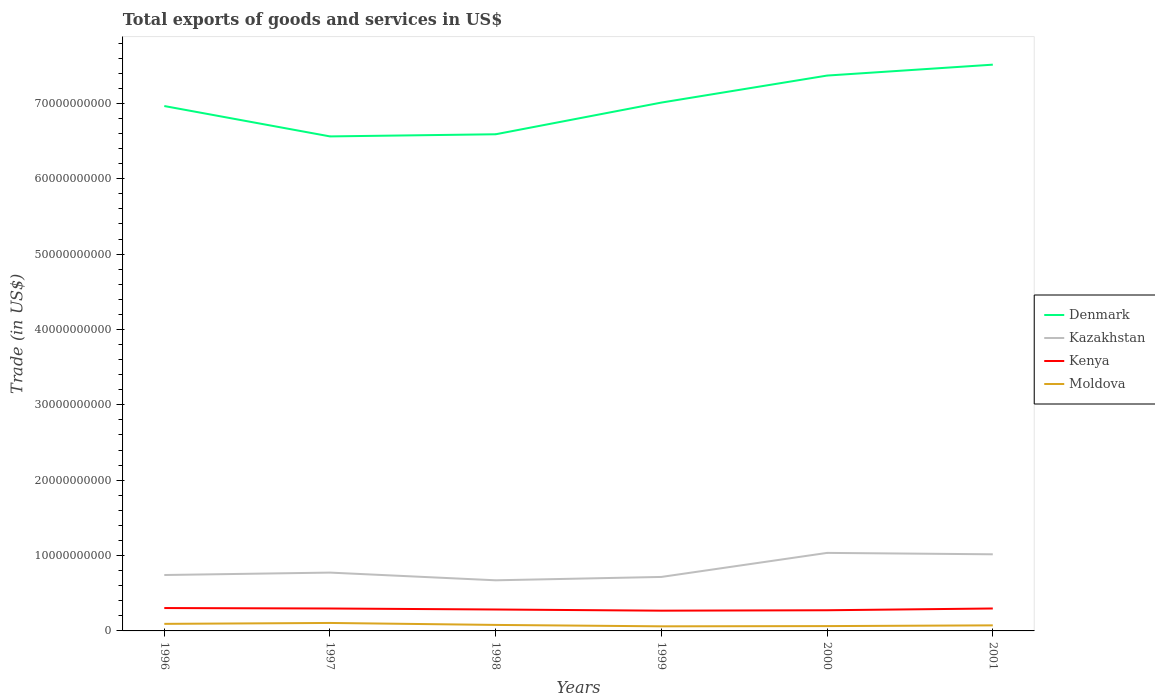Does the line corresponding to Kenya intersect with the line corresponding to Kazakhstan?
Provide a short and direct response. No. Is the number of lines equal to the number of legend labels?
Give a very brief answer. Yes. Across all years, what is the maximum total exports of goods and services in Moldova?
Your response must be concise. 6.10e+08. What is the total total exports of goods and services in Moldova in the graph?
Your answer should be compact. 3.19e+08. What is the difference between the highest and the second highest total exports of goods and services in Moldova?
Provide a short and direct response. 4.48e+08. Is the total exports of goods and services in Moldova strictly greater than the total exports of goods and services in Kazakhstan over the years?
Ensure brevity in your answer.  Yes. Are the values on the major ticks of Y-axis written in scientific E-notation?
Your answer should be very brief. No. How many legend labels are there?
Your answer should be compact. 4. How are the legend labels stacked?
Give a very brief answer. Vertical. What is the title of the graph?
Your response must be concise. Total exports of goods and services in US$. Does "Morocco" appear as one of the legend labels in the graph?
Give a very brief answer. No. What is the label or title of the X-axis?
Make the answer very short. Years. What is the label or title of the Y-axis?
Offer a very short reply. Trade (in US$). What is the Trade (in US$) of Denmark in 1996?
Your answer should be compact. 6.96e+1. What is the Trade (in US$) in Kazakhstan in 1996?
Offer a terse response. 7.42e+09. What is the Trade (in US$) in Kenya in 1996?
Your answer should be compact. 3.04e+09. What is the Trade (in US$) of Moldova in 1996?
Make the answer very short. 9.37e+08. What is the Trade (in US$) of Denmark in 1997?
Your answer should be very brief. 6.56e+1. What is the Trade (in US$) in Kazakhstan in 1997?
Give a very brief answer. 7.74e+09. What is the Trade (in US$) of Kenya in 1997?
Give a very brief answer. 2.98e+09. What is the Trade (in US$) of Moldova in 1997?
Keep it short and to the point. 1.06e+09. What is the Trade (in US$) in Denmark in 1998?
Give a very brief answer. 6.59e+1. What is the Trade (in US$) of Kazakhstan in 1998?
Offer a terse response. 6.72e+09. What is the Trade (in US$) of Kenya in 1998?
Provide a succinct answer. 2.84e+09. What is the Trade (in US$) of Moldova in 1998?
Keep it short and to the point. 7.96e+08. What is the Trade (in US$) in Denmark in 1999?
Make the answer very short. 7.01e+1. What is the Trade (in US$) in Kazakhstan in 1999?
Keep it short and to the point. 7.16e+09. What is the Trade (in US$) of Kenya in 1999?
Offer a terse response. 2.69e+09. What is the Trade (in US$) in Moldova in 1999?
Keep it short and to the point. 6.10e+08. What is the Trade (in US$) of Denmark in 2000?
Offer a very short reply. 7.37e+1. What is the Trade (in US$) in Kazakhstan in 2000?
Give a very brief answer. 1.04e+1. What is the Trade (in US$) of Kenya in 2000?
Provide a short and direct response. 2.74e+09. What is the Trade (in US$) of Moldova in 2000?
Ensure brevity in your answer.  6.41e+08. What is the Trade (in US$) in Denmark in 2001?
Give a very brief answer. 7.51e+1. What is the Trade (in US$) of Kazakhstan in 2001?
Ensure brevity in your answer.  1.02e+1. What is the Trade (in US$) in Kenya in 2001?
Provide a short and direct response. 2.98e+09. What is the Trade (in US$) of Moldova in 2001?
Ensure brevity in your answer.  7.38e+08. Across all years, what is the maximum Trade (in US$) of Denmark?
Your response must be concise. 7.51e+1. Across all years, what is the maximum Trade (in US$) in Kazakhstan?
Make the answer very short. 1.04e+1. Across all years, what is the maximum Trade (in US$) of Kenya?
Keep it short and to the point. 3.04e+09. Across all years, what is the maximum Trade (in US$) in Moldova?
Offer a very short reply. 1.06e+09. Across all years, what is the minimum Trade (in US$) in Denmark?
Your response must be concise. 6.56e+1. Across all years, what is the minimum Trade (in US$) of Kazakhstan?
Your response must be concise. 6.72e+09. Across all years, what is the minimum Trade (in US$) of Kenya?
Keep it short and to the point. 2.69e+09. Across all years, what is the minimum Trade (in US$) in Moldova?
Your response must be concise. 6.10e+08. What is the total Trade (in US$) of Denmark in the graph?
Give a very brief answer. 4.20e+11. What is the total Trade (in US$) in Kazakhstan in the graph?
Your answer should be compact. 4.96e+1. What is the total Trade (in US$) in Kenya in the graph?
Your response must be concise. 1.73e+1. What is the total Trade (in US$) in Moldova in the graph?
Offer a very short reply. 4.78e+09. What is the difference between the Trade (in US$) of Denmark in 1996 and that in 1997?
Your answer should be compact. 4.03e+09. What is the difference between the Trade (in US$) in Kazakhstan in 1996 and that in 1997?
Make the answer very short. -3.21e+08. What is the difference between the Trade (in US$) of Kenya in 1996 and that in 1997?
Your answer should be very brief. 6.01e+07. What is the difference between the Trade (in US$) in Moldova in 1996 and that in 1997?
Your response must be concise. -1.21e+08. What is the difference between the Trade (in US$) of Denmark in 1996 and that in 1998?
Your response must be concise. 3.75e+09. What is the difference between the Trade (in US$) of Kazakhstan in 1996 and that in 1998?
Make the answer very short. 7.02e+08. What is the difference between the Trade (in US$) in Kenya in 1996 and that in 1998?
Give a very brief answer. 1.93e+08. What is the difference between the Trade (in US$) of Moldova in 1996 and that in 1998?
Provide a succinct answer. 1.41e+08. What is the difference between the Trade (in US$) of Denmark in 1996 and that in 1999?
Your answer should be compact. -4.60e+08. What is the difference between the Trade (in US$) in Kazakhstan in 1996 and that in 1999?
Your answer should be compact. 2.55e+08. What is the difference between the Trade (in US$) of Kenya in 1996 and that in 1999?
Keep it short and to the point. 3.49e+08. What is the difference between the Trade (in US$) in Moldova in 1996 and that in 1999?
Ensure brevity in your answer.  3.27e+08. What is the difference between the Trade (in US$) in Denmark in 1996 and that in 2000?
Ensure brevity in your answer.  -4.04e+09. What is the difference between the Trade (in US$) in Kazakhstan in 1996 and that in 2000?
Give a very brief answer. -2.93e+09. What is the difference between the Trade (in US$) of Kenya in 1996 and that in 2000?
Offer a terse response. 2.93e+08. What is the difference between the Trade (in US$) of Moldova in 1996 and that in 2000?
Provide a short and direct response. 2.95e+08. What is the difference between the Trade (in US$) of Denmark in 1996 and that in 2001?
Ensure brevity in your answer.  -5.49e+09. What is the difference between the Trade (in US$) in Kazakhstan in 1996 and that in 2001?
Your response must be concise. -2.75e+09. What is the difference between the Trade (in US$) of Kenya in 1996 and that in 2001?
Ensure brevity in your answer.  5.77e+07. What is the difference between the Trade (in US$) of Moldova in 1996 and that in 2001?
Provide a short and direct response. 1.99e+08. What is the difference between the Trade (in US$) of Denmark in 1997 and that in 1998?
Your answer should be very brief. -2.83e+08. What is the difference between the Trade (in US$) in Kazakhstan in 1997 and that in 1998?
Keep it short and to the point. 1.02e+09. What is the difference between the Trade (in US$) in Kenya in 1997 and that in 1998?
Provide a short and direct response. 1.33e+08. What is the difference between the Trade (in US$) of Moldova in 1997 and that in 1998?
Offer a very short reply. 2.62e+08. What is the difference between the Trade (in US$) in Denmark in 1997 and that in 1999?
Provide a succinct answer. -4.49e+09. What is the difference between the Trade (in US$) of Kazakhstan in 1997 and that in 1999?
Your answer should be compact. 5.76e+08. What is the difference between the Trade (in US$) in Kenya in 1997 and that in 1999?
Make the answer very short. 2.89e+08. What is the difference between the Trade (in US$) in Moldova in 1997 and that in 1999?
Ensure brevity in your answer.  4.48e+08. What is the difference between the Trade (in US$) of Denmark in 1997 and that in 2000?
Ensure brevity in your answer.  -8.07e+09. What is the difference between the Trade (in US$) in Kazakhstan in 1997 and that in 2000?
Keep it short and to the point. -2.61e+09. What is the difference between the Trade (in US$) in Kenya in 1997 and that in 2000?
Keep it short and to the point. 2.33e+08. What is the difference between the Trade (in US$) in Moldova in 1997 and that in 2000?
Provide a succinct answer. 4.16e+08. What is the difference between the Trade (in US$) in Denmark in 1997 and that in 2001?
Give a very brief answer. -9.52e+09. What is the difference between the Trade (in US$) of Kazakhstan in 1997 and that in 2001?
Offer a very short reply. -2.43e+09. What is the difference between the Trade (in US$) in Kenya in 1997 and that in 2001?
Give a very brief answer. -2.40e+06. What is the difference between the Trade (in US$) in Moldova in 1997 and that in 2001?
Offer a terse response. 3.19e+08. What is the difference between the Trade (in US$) in Denmark in 1998 and that in 1999?
Your answer should be very brief. -4.21e+09. What is the difference between the Trade (in US$) in Kazakhstan in 1998 and that in 1999?
Make the answer very short. -4.47e+08. What is the difference between the Trade (in US$) in Kenya in 1998 and that in 1999?
Your answer should be compact. 1.56e+08. What is the difference between the Trade (in US$) of Moldova in 1998 and that in 1999?
Provide a short and direct response. 1.86e+08. What is the difference between the Trade (in US$) of Denmark in 1998 and that in 2000?
Offer a very short reply. -7.79e+09. What is the difference between the Trade (in US$) in Kazakhstan in 1998 and that in 2000?
Offer a very short reply. -3.64e+09. What is the difference between the Trade (in US$) of Kenya in 1998 and that in 2000?
Make the answer very short. 9.99e+07. What is the difference between the Trade (in US$) in Moldova in 1998 and that in 2000?
Your response must be concise. 1.54e+08. What is the difference between the Trade (in US$) of Denmark in 1998 and that in 2001?
Your answer should be compact. -9.24e+09. What is the difference between the Trade (in US$) in Kazakhstan in 1998 and that in 2001?
Make the answer very short. -3.45e+09. What is the difference between the Trade (in US$) of Kenya in 1998 and that in 2001?
Your answer should be compact. -1.35e+08. What is the difference between the Trade (in US$) of Moldova in 1998 and that in 2001?
Keep it short and to the point. 5.75e+07. What is the difference between the Trade (in US$) of Denmark in 1999 and that in 2000?
Keep it short and to the point. -3.58e+09. What is the difference between the Trade (in US$) in Kazakhstan in 1999 and that in 2000?
Your response must be concise. -3.19e+09. What is the difference between the Trade (in US$) of Kenya in 1999 and that in 2000?
Offer a very short reply. -5.62e+07. What is the difference between the Trade (in US$) of Moldova in 1999 and that in 2000?
Your answer should be very brief. -3.15e+07. What is the difference between the Trade (in US$) of Denmark in 1999 and that in 2001?
Your response must be concise. -5.03e+09. What is the difference between the Trade (in US$) in Kazakhstan in 1999 and that in 2001?
Provide a succinct answer. -3.00e+09. What is the difference between the Trade (in US$) of Kenya in 1999 and that in 2001?
Provide a succinct answer. -2.91e+08. What is the difference between the Trade (in US$) of Moldova in 1999 and that in 2001?
Your answer should be very brief. -1.28e+08. What is the difference between the Trade (in US$) in Denmark in 2000 and that in 2001?
Keep it short and to the point. -1.45e+09. What is the difference between the Trade (in US$) of Kazakhstan in 2000 and that in 2001?
Make the answer very short. 1.87e+08. What is the difference between the Trade (in US$) in Kenya in 2000 and that in 2001?
Make the answer very short. -2.35e+08. What is the difference between the Trade (in US$) in Moldova in 2000 and that in 2001?
Give a very brief answer. -9.68e+07. What is the difference between the Trade (in US$) in Denmark in 1996 and the Trade (in US$) in Kazakhstan in 1997?
Provide a short and direct response. 6.19e+1. What is the difference between the Trade (in US$) of Denmark in 1996 and the Trade (in US$) of Kenya in 1997?
Ensure brevity in your answer.  6.67e+1. What is the difference between the Trade (in US$) of Denmark in 1996 and the Trade (in US$) of Moldova in 1997?
Your response must be concise. 6.86e+1. What is the difference between the Trade (in US$) in Kazakhstan in 1996 and the Trade (in US$) in Kenya in 1997?
Give a very brief answer. 4.44e+09. What is the difference between the Trade (in US$) in Kazakhstan in 1996 and the Trade (in US$) in Moldova in 1997?
Your answer should be compact. 6.36e+09. What is the difference between the Trade (in US$) in Kenya in 1996 and the Trade (in US$) in Moldova in 1997?
Make the answer very short. 1.98e+09. What is the difference between the Trade (in US$) of Denmark in 1996 and the Trade (in US$) of Kazakhstan in 1998?
Provide a succinct answer. 6.29e+1. What is the difference between the Trade (in US$) in Denmark in 1996 and the Trade (in US$) in Kenya in 1998?
Keep it short and to the point. 6.68e+1. What is the difference between the Trade (in US$) in Denmark in 1996 and the Trade (in US$) in Moldova in 1998?
Provide a short and direct response. 6.89e+1. What is the difference between the Trade (in US$) in Kazakhstan in 1996 and the Trade (in US$) in Kenya in 1998?
Provide a short and direct response. 4.58e+09. What is the difference between the Trade (in US$) of Kazakhstan in 1996 and the Trade (in US$) of Moldova in 1998?
Offer a very short reply. 6.62e+09. What is the difference between the Trade (in US$) of Kenya in 1996 and the Trade (in US$) of Moldova in 1998?
Make the answer very short. 2.24e+09. What is the difference between the Trade (in US$) of Denmark in 1996 and the Trade (in US$) of Kazakhstan in 1999?
Keep it short and to the point. 6.25e+1. What is the difference between the Trade (in US$) of Denmark in 1996 and the Trade (in US$) of Kenya in 1999?
Your answer should be very brief. 6.70e+1. What is the difference between the Trade (in US$) in Denmark in 1996 and the Trade (in US$) in Moldova in 1999?
Your answer should be compact. 6.90e+1. What is the difference between the Trade (in US$) in Kazakhstan in 1996 and the Trade (in US$) in Kenya in 1999?
Your response must be concise. 4.73e+09. What is the difference between the Trade (in US$) of Kazakhstan in 1996 and the Trade (in US$) of Moldova in 1999?
Provide a short and direct response. 6.81e+09. What is the difference between the Trade (in US$) of Kenya in 1996 and the Trade (in US$) of Moldova in 1999?
Make the answer very short. 2.43e+09. What is the difference between the Trade (in US$) of Denmark in 1996 and the Trade (in US$) of Kazakhstan in 2000?
Your response must be concise. 5.93e+1. What is the difference between the Trade (in US$) of Denmark in 1996 and the Trade (in US$) of Kenya in 2000?
Your answer should be compact. 6.69e+1. What is the difference between the Trade (in US$) in Denmark in 1996 and the Trade (in US$) in Moldova in 2000?
Provide a short and direct response. 6.90e+1. What is the difference between the Trade (in US$) in Kazakhstan in 1996 and the Trade (in US$) in Kenya in 2000?
Provide a short and direct response. 4.68e+09. What is the difference between the Trade (in US$) of Kazakhstan in 1996 and the Trade (in US$) of Moldova in 2000?
Your response must be concise. 6.78e+09. What is the difference between the Trade (in US$) of Kenya in 1996 and the Trade (in US$) of Moldova in 2000?
Your response must be concise. 2.39e+09. What is the difference between the Trade (in US$) in Denmark in 1996 and the Trade (in US$) in Kazakhstan in 2001?
Your answer should be very brief. 5.95e+1. What is the difference between the Trade (in US$) of Denmark in 1996 and the Trade (in US$) of Kenya in 2001?
Your answer should be compact. 6.67e+1. What is the difference between the Trade (in US$) in Denmark in 1996 and the Trade (in US$) in Moldova in 2001?
Keep it short and to the point. 6.89e+1. What is the difference between the Trade (in US$) in Kazakhstan in 1996 and the Trade (in US$) in Kenya in 2001?
Your response must be concise. 4.44e+09. What is the difference between the Trade (in US$) in Kazakhstan in 1996 and the Trade (in US$) in Moldova in 2001?
Make the answer very short. 6.68e+09. What is the difference between the Trade (in US$) of Kenya in 1996 and the Trade (in US$) of Moldova in 2001?
Offer a very short reply. 2.30e+09. What is the difference between the Trade (in US$) in Denmark in 1997 and the Trade (in US$) in Kazakhstan in 1998?
Your answer should be compact. 5.89e+1. What is the difference between the Trade (in US$) of Denmark in 1997 and the Trade (in US$) of Kenya in 1998?
Ensure brevity in your answer.  6.28e+1. What is the difference between the Trade (in US$) of Denmark in 1997 and the Trade (in US$) of Moldova in 1998?
Your answer should be compact. 6.48e+1. What is the difference between the Trade (in US$) in Kazakhstan in 1997 and the Trade (in US$) in Kenya in 1998?
Make the answer very short. 4.90e+09. What is the difference between the Trade (in US$) in Kazakhstan in 1997 and the Trade (in US$) in Moldova in 1998?
Keep it short and to the point. 6.94e+09. What is the difference between the Trade (in US$) of Kenya in 1997 and the Trade (in US$) of Moldova in 1998?
Give a very brief answer. 2.18e+09. What is the difference between the Trade (in US$) of Denmark in 1997 and the Trade (in US$) of Kazakhstan in 1999?
Your response must be concise. 5.85e+1. What is the difference between the Trade (in US$) in Denmark in 1997 and the Trade (in US$) in Kenya in 1999?
Offer a terse response. 6.29e+1. What is the difference between the Trade (in US$) of Denmark in 1997 and the Trade (in US$) of Moldova in 1999?
Make the answer very short. 6.50e+1. What is the difference between the Trade (in US$) in Kazakhstan in 1997 and the Trade (in US$) in Kenya in 1999?
Provide a short and direct response. 5.05e+09. What is the difference between the Trade (in US$) of Kazakhstan in 1997 and the Trade (in US$) of Moldova in 1999?
Provide a short and direct response. 7.13e+09. What is the difference between the Trade (in US$) in Kenya in 1997 and the Trade (in US$) in Moldova in 1999?
Your response must be concise. 2.37e+09. What is the difference between the Trade (in US$) in Denmark in 1997 and the Trade (in US$) in Kazakhstan in 2000?
Provide a short and direct response. 5.53e+1. What is the difference between the Trade (in US$) of Denmark in 1997 and the Trade (in US$) of Kenya in 2000?
Your response must be concise. 6.29e+1. What is the difference between the Trade (in US$) of Denmark in 1997 and the Trade (in US$) of Moldova in 2000?
Your response must be concise. 6.50e+1. What is the difference between the Trade (in US$) in Kazakhstan in 1997 and the Trade (in US$) in Kenya in 2000?
Keep it short and to the point. 5.00e+09. What is the difference between the Trade (in US$) of Kazakhstan in 1997 and the Trade (in US$) of Moldova in 2000?
Your answer should be very brief. 7.10e+09. What is the difference between the Trade (in US$) of Kenya in 1997 and the Trade (in US$) of Moldova in 2000?
Offer a terse response. 2.33e+09. What is the difference between the Trade (in US$) of Denmark in 1997 and the Trade (in US$) of Kazakhstan in 2001?
Your response must be concise. 5.55e+1. What is the difference between the Trade (in US$) in Denmark in 1997 and the Trade (in US$) in Kenya in 2001?
Provide a short and direct response. 6.26e+1. What is the difference between the Trade (in US$) of Denmark in 1997 and the Trade (in US$) of Moldova in 2001?
Offer a very short reply. 6.49e+1. What is the difference between the Trade (in US$) in Kazakhstan in 1997 and the Trade (in US$) in Kenya in 2001?
Your answer should be very brief. 4.76e+09. What is the difference between the Trade (in US$) in Kazakhstan in 1997 and the Trade (in US$) in Moldova in 2001?
Your answer should be compact. 7.00e+09. What is the difference between the Trade (in US$) of Kenya in 1997 and the Trade (in US$) of Moldova in 2001?
Provide a short and direct response. 2.24e+09. What is the difference between the Trade (in US$) in Denmark in 1998 and the Trade (in US$) in Kazakhstan in 1999?
Your answer should be very brief. 5.87e+1. What is the difference between the Trade (in US$) of Denmark in 1998 and the Trade (in US$) of Kenya in 1999?
Your answer should be very brief. 6.32e+1. What is the difference between the Trade (in US$) of Denmark in 1998 and the Trade (in US$) of Moldova in 1999?
Ensure brevity in your answer.  6.53e+1. What is the difference between the Trade (in US$) of Kazakhstan in 1998 and the Trade (in US$) of Kenya in 1999?
Your answer should be very brief. 4.03e+09. What is the difference between the Trade (in US$) in Kazakhstan in 1998 and the Trade (in US$) in Moldova in 1999?
Offer a terse response. 6.11e+09. What is the difference between the Trade (in US$) of Kenya in 1998 and the Trade (in US$) of Moldova in 1999?
Offer a terse response. 2.23e+09. What is the difference between the Trade (in US$) of Denmark in 1998 and the Trade (in US$) of Kazakhstan in 2000?
Offer a very short reply. 5.55e+1. What is the difference between the Trade (in US$) in Denmark in 1998 and the Trade (in US$) in Kenya in 2000?
Make the answer very short. 6.32e+1. What is the difference between the Trade (in US$) of Denmark in 1998 and the Trade (in US$) of Moldova in 2000?
Your answer should be very brief. 6.53e+1. What is the difference between the Trade (in US$) in Kazakhstan in 1998 and the Trade (in US$) in Kenya in 2000?
Ensure brevity in your answer.  3.97e+09. What is the difference between the Trade (in US$) in Kazakhstan in 1998 and the Trade (in US$) in Moldova in 2000?
Give a very brief answer. 6.08e+09. What is the difference between the Trade (in US$) in Kenya in 1998 and the Trade (in US$) in Moldova in 2000?
Ensure brevity in your answer.  2.20e+09. What is the difference between the Trade (in US$) of Denmark in 1998 and the Trade (in US$) of Kazakhstan in 2001?
Give a very brief answer. 5.57e+1. What is the difference between the Trade (in US$) in Denmark in 1998 and the Trade (in US$) in Kenya in 2001?
Offer a terse response. 6.29e+1. What is the difference between the Trade (in US$) of Denmark in 1998 and the Trade (in US$) of Moldova in 2001?
Give a very brief answer. 6.52e+1. What is the difference between the Trade (in US$) in Kazakhstan in 1998 and the Trade (in US$) in Kenya in 2001?
Offer a very short reply. 3.74e+09. What is the difference between the Trade (in US$) of Kazakhstan in 1998 and the Trade (in US$) of Moldova in 2001?
Provide a short and direct response. 5.98e+09. What is the difference between the Trade (in US$) in Kenya in 1998 and the Trade (in US$) in Moldova in 2001?
Your response must be concise. 2.10e+09. What is the difference between the Trade (in US$) in Denmark in 1999 and the Trade (in US$) in Kazakhstan in 2000?
Provide a short and direct response. 5.98e+1. What is the difference between the Trade (in US$) of Denmark in 1999 and the Trade (in US$) of Kenya in 2000?
Offer a very short reply. 6.74e+1. What is the difference between the Trade (in US$) in Denmark in 1999 and the Trade (in US$) in Moldova in 2000?
Ensure brevity in your answer.  6.95e+1. What is the difference between the Trade (in US$) of Kazakhstan in 1999 and the Trade (in US$) of Kenya in 2000?
Your answer should be compact. 4.42e+09. What is the difference between the Trade (in US$) of Kazakhstan in 1999 and the Trade (in US$) of Moldova in 2000?
Provide a succinct answer. 6.52e+09. What is the difference between the Trade (in US$) of Kenya in 1999 and the Trade (in US$) of Moldova in 2000?
Ensure brevity in your answer.  2.05e+09. What is the difference between the Trade (in US$) of Denmark in 1999 and the Trade (in US$) of Kazakhstan in 2001?
Give a very brief answer. 5.99e+1. What is the difference between the Trade (in US$) of Denmark in 1999 and the Trade (in US$) of Kenya in 2001?
Offer a very short reply. 6.71e+1. What is the difference between the Trade (in US$) of Denmark in 1999 and the Trade (in US$) of Moldova in 2001?
Offer a terse response. 6.94e+1. What is the difference between the Trade (in US$) in Kazakhstan in 1999 and the Trade (in US$) in Kenya in 2001?
Your response must be concise. 4.19e+09. What is the difference between the Trade (in US$) of Kazakhstan in 1999 and the Trade (in US$) of Moldova in 2001?
Provide a succinct answer. 6.43e+09. What is the difference between the Trade (in US$) of Kenya in 1999 and the Trade (in US$) of Moldova in 2001?
Your answer should be compact. 1.95e+09. What is the difference between the Trade (in US$) of Denmark in 2000 and the Trade (in US$) of Kazakhstan in 2001?
Provide a short and direct response. 6.35e+1. What is the difference between the Trade (in US$) in Denmark in 2000 and the Trade (in US$) in Kenya in 2001?
Keep it short and to the point. 7.07e+1. What is the difference between the Trade (in US$) in Denmark in 2000 and the Trade (in US$) in Moldova in 2001?
Your answer should be very brief. 7.30e+1. What is the difference between the Trade (in US$) in Kazakhstan in 2000 and the Trade (in US$) in Kenya in 2001?
Your answer should be compact. 7.38e+09. What is the difference between the Trade (in US$) of Kazakhstan in 2000 and the Trade (in US$) of Moldova in 2001?
Offer a terse response. 9.62e+09. What is the difference between the Trade (in US$) of Kenya in 2000 and the Trade (in US$) of Moldova in 2001?
Your response must be concise. 2.00e+09. What is the average Trade (in US$) of Denmark per year?
Ensure brevity in your answer.  7.00e+1. What is the average Trade (in US$) in Kazakhstan per year?
Your response must be concise. 8.26e+09. What is the average Trade (in US$) in Kenya per year?
Your answer should be very brief. 2.88e+09. What is the average Trade (in US$) of Moldova per year?
Offer a terse response. 7.97e+08. In the year 1996, what is the difference between the Trade (in US$) in Denmark and Trade (in US$) in Kazakhstan?
Your response must be concise. 6.22e+1. In the year 1996, what is the difference between the Trade (in US$) of Denmark and Trade (in US$) of Kenya?
Give a very brief answer. 6.66e+1. In the year 1996, what is the difference between the Trade (in US$) in Denmark and Trade (in US$) in Moldova?
Give a very brief answer. 6.87e+1. In the year 1996, what is the difference between the Trade (in US$) in Kazakhstan and Trade (in US$) in Kenya?
Your response must be concise. 4.38e+09. In the year 1996, what is the difference between the Trade (in US$) in Kazakhstan and Trade (in US$) in Moldova?
Make the answer very short. 6.48e+09. In the year 1996, what is the difference between the Trade (in US$) in Kenya and Trade (in US$) in Moldova?
Your answer should be very brief. 2.10e+09. In the year 1997, what is the difference between the Trade (in US$) of Denmark and Trade (in US$) of Kazakhstan?
Give a very brief answer. 5.79e+1. In the year 1997, what is the difference between the Trade (in US$) of Denmark and Trade (in US$) of Kenya?
Provide a succinct answer. 6.26e+1. In the year 1997, what is the difference between the Trade (in US$) in Denmark and Trade (in US$) in Moldova?
Offer a very short reply. 6.46e+1. In the year 1997, what is the difference between the Trade (in US$) in Kazakhstan and Trade (in US$) in Kenya?
Give a very brief answer. 4.76e+09. In the year 1997, what is the difference between the Trade (in US$) of Kazakhstan and Trade (in US$) of Moldova?
Give a very brief answer. 6.68e+09. In the year 1997, what is the difference between the Trade (in US$) in Kenya and Trade (in US$) in Moldova?
Offer a terse response. 1.92e+09. In the year 1998, what is the difference between the Trade (in US$) in Denmark and Trade (in US$) in Kazakhstan?
Offer a very short reply. 5.92e+1. In the year 1998, what is the difference between the Trade (in US$) in Denmark and Trade (in US$) in Kenya?
Make the answer very short. 6.31e+1. In the year 1998, what is the difference between the Trade (in US$) of Denmark and Trade (in US$) of Moldova?
Provide a short and direct response. 6.51e+1. In the year 1998, what is the difference between the Trade (in US$) of Kazakhstan and Trade (in US$) of Kenya?
Keep it short and to the point. 3.87e+09. In the year 1998, what is the difference between the Trade (in US$) in Kazakhstan and Trade (in US$) in Moldova?
Offer a very short reply. 5.92e+09. In the year 1998, what is the difference between the Trade (in US$) of Kenya and Trade (in US$) of Moldova?
Your answer should be compact. 2.05e+09. In the year 1999, what is the difference between the Trade (in US$) of Denmark and Trade (in US$) of Kazakhstan?
Your answer should be compact. 6.29e+1. In the year 1999, what is the difference between the Trade (in US$) in Denmark and Trade (in US$) in Kenya?
Provide a short and direct response. 6.74e+1. In the year 1999, what is the difference between the Trade (in US$) in Denmark and Trade (in US$) in Moldova?
Provide a short and direct response. 6.95e+1. In the year 1999, what is the difference between the Trade (in US$) in Kazakhstan and Trade (in US$) in Kenya?
Make the answer very short. 4.48e+09. In the year 1999, what is the difference between the Trade (in US$) of Kazakhstan and Trade (in US$) of Moldova?
Keep it short and to the point. 6.55e+09. In the year 1999, what is the difference between the Trade (in US$) of Kenya and Trade (in US$) of Moldova?
Your response must be concise. 2.08e+09. In the year 2000, what is the difference between the Trade (in US$) of Denmark and Trade (in US$) of Kazakhstan?
Your answer should be compact. 6.33e+1. In the year 2000, what is the difference between the Trade (in US$) in Denmark and Trade (in US$) in Kenya?
Offer a very short reply. 7.09e+1. In the year 2000, what is the difference between the Trade (in US$) of Denmark and Trade (in US$) of Moldova?
Your answer should be very brief. 7.30e+1. In the year 2000, what is the difference between the Trade (in US$) in Kazakhstan and Trade (in US$) in Kenya?
Make the answer very short. 7.61e+09. In the year 2000, what is the difference between the Trade (in US$) in Kazakhstan and Trade (in US$) in Moldova?
Your answer should be compact. 9.71e+09. In the year 2000, what is the difference between the Trade (in US$) in Kenya and Trade (in US$) in Moldova?
Offer a very short reply. 2.10e+09. In the year 2001, what is the difference between the Trade (in US$) of Denmark and Trade (in US$) of Kazakhstan?
Your answer should be compact. 6.50e+1. In the year 2001, what is the difference between the Trade (in US$) in Denmark and Trade (in US$) in Kenya?
Offer a terse response. 7.22e+1. In the year 2001, what is the difference between the Trade (in US$) in Denmark and Trade (in US$) in Moldova?
Offer a terse response. 7.44e+1. In the year 2001, what is the difference between the Trade (in US$) in Kazakhstan and Trade (in US$) in Kenya?
Keep it short and to the point. 7.19e+09. In the year 2001, what is the difference between the Trade (in US$) in Kazakhstan and Trade (in US$) in Moldova?
Make the answer very short. 9.43e+09. In the year 2001, what is the difference between the Trade (in US$) of Kenya and Trade (in US$) of Moldova?
Your answer should be very brief. 2.24e+09. What is the ratio of the Trade (in US$) of Denmark in 1996 to that in 1997?
Your answer should be very brief. 1.06. What is the ratio of the Trade (in US$) of Kazakhstan in 1996 to that in 1997?
Your response must be concise. 0.96. What is the ratio of the Trade (in US$) in Kenya in 1996 to that in 1997?
Your response must be concise. 1.02. What is the ratio of the Trade (in US$) in Moldova in 1996 to that in 1997?
Offer a terse response. 0.89. What is the ratio of the Trade (in US$) of Denmark in 1996 to that in 1998?
Provide a succinct answer. 1.06. What is the ratio of the Trade (in US$) in Kazakhstan in 1996 to that in 1998?
Your answer should be compact. 1.1. What is the ratio of the Trade (in US$) of Kenya in 1996 to that in 1998?
Your answer should be very brief. 1.07. What is the ratio of the Trade (in US$) of Moldova in 1996 to that in 1998?
Provide a short and direct response. 1.18. What is the ratio of the Trade (in US$) in Denmark in 1996 to that in 1999?
Offer a very short reply. 0.99. What is the ratio of the Trade (in US$) of Kazakhstan in 1996 to that in 1999?
Provide a succinct answer. 1.04. What is the ratio of the Trade (in US$) of Kenya in 1996 to that in 1999?
Offer a very short reply. 1.13. What is the ratio of the Trade (in US$) in Moldova in 1996 to that in 1999?
Offer a very short reply. 1.54. What is the ratio of the Trade (in US$) of Denmark in 1996 to that in 2000?
Ensure brevity in your answer.  0.95. What is the ratio of the Trade (in US$) of Kazakhstan in 1996 to that in 2000?
Give a very brief answer. 0.72. What is the ratio of the Trade (in US$) in Kenya in 1996 to that in 2000?
Offer a very short reply. 1.11. What is the ratio of the Trade (in US$) in Moldova in 1996 to that in 2000?
Your answer should be compact. 1.46. What is the ratio of the Trade (in US$) of Denmark in 1996 to that in 2001?
Your answer should be very brief. 0.93. What is the ratio of the Trade (in US$) of Kazakhstan in 1996 to that in 2001?
Make the answer very short. 0.73. What is the ratio of the Trade (in US$) of Kenya in 1996 to that in 2001?
Ensure brevity in your answer.  1.02. What is the ratio of the Trade (in US$) in Moldova in 1996 to that in 2001?
Keep it short and to the point. 1.27. What is the ratio of the Trade (in US$) in Denmark in 1997 to that in 1998?
Provide a short and direct response. 1. What is the ratio of the Trade (in US$) in Kazakhstan in 1997 to that in 1998?
Offer a terse response. 1.15. What is the ratio of the Trade (in US$) of Kenya in 1997 to that in 1998?
Offer a very short reply. 1.05. What is the ratio of the Trade (in US$) in Moldova in 1997 to that in 1998?
Ensure brevity in your answer.  1.33. What is the ratio of the Trade (in US$) of Denmark in 1997 to that in 1999?
Offer a very short reply. 0.94. What is the ratio of the Trade (in US$) of Kazakhstan in 1997 to that in 1999?
Provide a short and direct response. 1.08. What is the ratio of the Trade (in US$) of Kenya in 1997 to that in 1999?
Your answer should be very brief. 1.11. What is the ratio of the Trade (in US$) in Moldova in 1997 to that in 1999?
Provide a short and direct response. 1.73. What is the ratio of the Trade (in US$) in Denmark in 1997 to that in 2000?
Give a very brief answer. 0.89. What is the ratio of the Trade (in US$) of Kazakhstan in 1997 to that in 2000?
Offer a very short reply. 0.75. What is the ratio of the Trade (in US$) of Kenya in 1997 to that in 2000?
Provide a succinct answer. 1.08. What is the ratio of the Trade (in US$) of Moldova in 1997 to that in 2000?
Your response must be concise. 1.65. What is the ratio of the Trade (in US$) of Denmark in 1997 to that in 2001?
Provide a short and direct response. 0.87. What is the ratio of the Trade (in US$) of Kazakhstan in 1997 to that in 2001?
Keep it short and to the point. 0.76. What is the ratio of the Trade (in US$) of Moldova in 1997 to that in 2001?
Offer a terse response. 1.43. What is the ratio of the Trade (in US$) in Kazakhstan in 1998 to that in 1999?
Your answer should be very brief. 0.94. What is the ratio of the Trade (in US$) in Kenya in 1998 to that in 1999?
Offer a terse response. 1.06. What is the ratio of the Trade (in US$) in Moldova in 1998 to that in 1999?
Offer a very short reply. 1.3. What is the ratio of the Trade (in US$) of Denmark in 1998 to that in 2000?
Keep it short and to the point. 0.89. What is the ratio of the Trade (in US$) of Kazakhstan in 1998 to that in 2000?
Ensure brevity in your answer.  0.65. What is the ratio of the Trade (in US$) in Kenya in 1998 to that in 2000?
Keep it short and to the point. 1.04. What is the ratio of the Trade (in US$) of Moldova in 1998 to that in 2000?
Your response must be concise. 1.24. What is the ratio of the Trade (in US$) of Denmark in 1998 to that in 2001?
Ensure brevity in your answer.  0.88. What is the ratio of the Trade (in US$) in Kazakhstan in 1998 to that in 2001?
Keep it short and to the point. 0.66. What is the ratio of the Trade (in US$) of Kenya in 1998 to that in 2001?
Your answer should be compact. 0.95. What is the ratio of the Trade (in US$) in Moldova in 1998 to that in 2001?
Your answer should be very brief. 1.08. What is the ratio of the Trade (in US$) of Denmark in 1999 to that in 2000?
Make the answer very short. 0.95. What is the ratio of the Trade (in US$) of Kazakhstan in 1999 to that in 2000?
Your answer should be compact. 0.69. What is the ratio of the Trade (in US$) of Kenya in 1999 to that in 2000?
Provide a succinct answer. 0.98. What is the ratio of the Trade (in US$) in Moldova in 1999 to that in 2000?
Offer a very short reply. 0.95. What is the ratio of the Trade (in US$) in Denmark in 1999 to that in 2001?
Your answer should be very brief. 0.93. What is the ratio of the Trade (in US$) of Kazakhstan in 1999 to that in 2001?
Offer a very short reply. 0.7. What is the ratio of the Trade (in US$) of Kenya in 1999 to that in 2001?
Provide a short and direct response. 0.9. What is the ratio of the Trade (in US$) of Moldova in 1999 to that in 2001?
Offer a terse response. 0.83. What is the ratio of the Trade (in US$) of Denmark in 2000 to that in 2001?
Provide a succinct answer. 0.98. What is the ratio of the Trade (in US$) of Kazakhstan in 2000 to that in 2001?
Your answer should be very brief. 1.02. What is the ratio of the Trade (in US$) in Kenya in 2000 to that in 2001?
Make the answer very short. 0.92. What is the ratio of the Trade (in US$) in Moldova in 2000 to that in 2001?
Keep it short and to the point. 0.87. What is the difference between the highest and the second highest Trade (in US$) in Denmark?
Make the answer very short. 1.45e+09. What is the difference between the highest and the second highest Trade (in US$) of Kazakhstan?
Offer a very short reply. 1.87e+08. What is the difference between the highest and the second highest Trade (in US$) of Kenya?
Offer a terse response. 5.77e+07. What is the difference between the highest and the second highest Trade (in US$) in Moldova?
Your answer should be very brief. 1.21e+08. What is the difference between the highest and the lowest Trade (in US$) of Denmark?
Provide a short and direct response. 9.52e+09. What is the difference between the highest and the lowest Trade (in US$) in Kazakhstan?
Your answer should be compact. 3.64e+09. What is the difference between the highest and the lowest Trade (in US$) of Kenya?
Give a very brief answer. 3.49e+08. What is the difference between the highest and the lowest Trade (in US$) in Moldova?
Offer a terse response. 4.48e+08. 